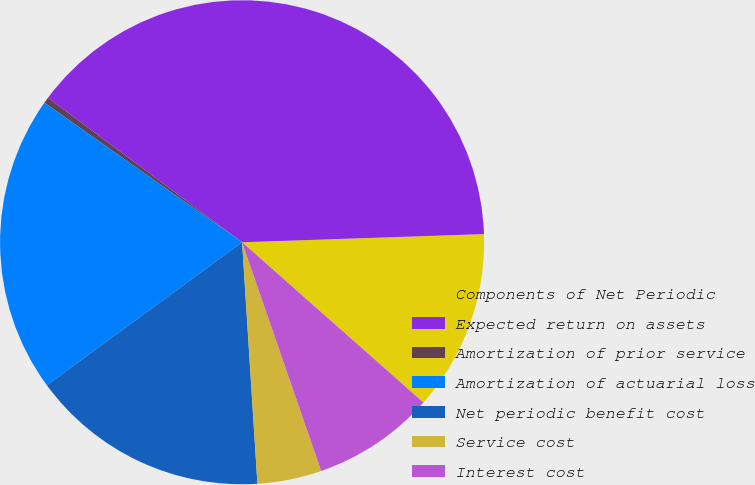<chart> <loc_0><loc_0><loc_500><loc_500><pie_chart><fcel>Components of Net Periodic<fcel>Expected return on assets<fcel>Amortization of prior service<fcel>Amortization of actuarial loss<fcel>Net periodic benefit cost<fcel>Service cost<fcel>Interest cost<nl><fcel>12.06%<fcel>39.28%<fcel>0.4%<fcel>19.84%<fcel>15.95%<fcel>4.29%<fcel>8.18%<nl></chart> 